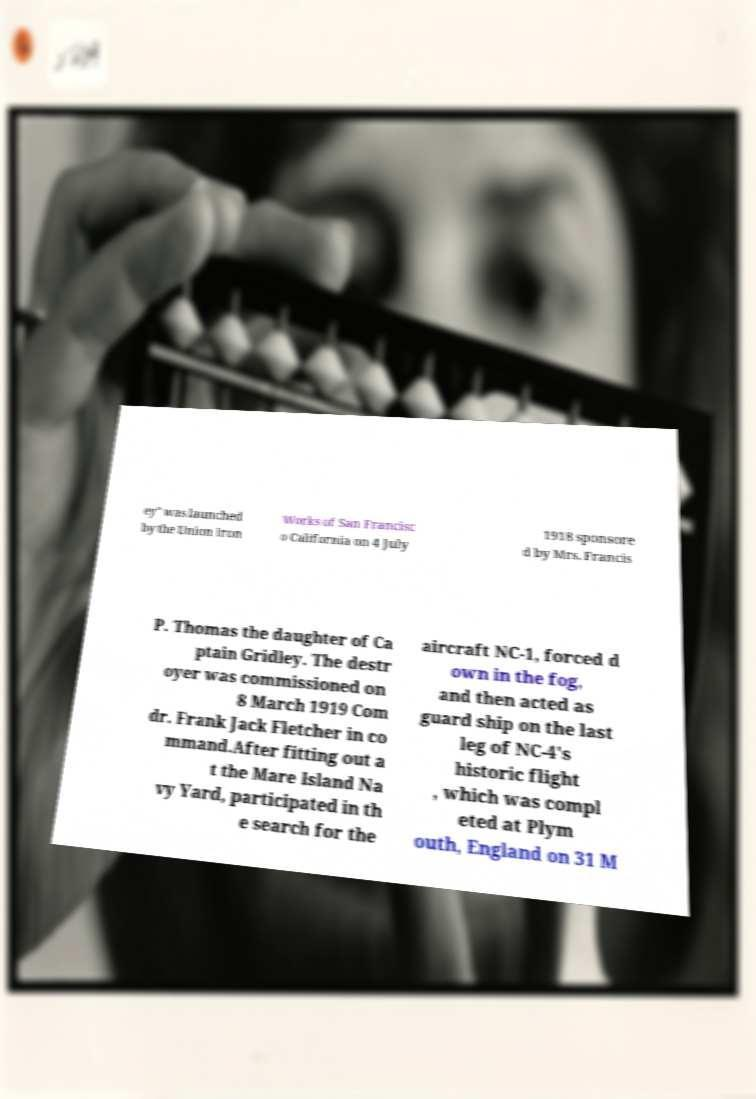Please identify and transcribe the text found in this image. ey" was launched by the Union Iron Works of San Francisc o California on 4 July 1918 sponsore d by Mrs. Francis P. Thomas the daughter of Ca ptain Gridley. The destr oyer was commissioned on 8 March 1919 Com dr. Frank Jack Fletcher in co mmand.After fitting out a t the Mare Island Na vy Yard, participated in th e search for the aircraft NC-1, forced d own in the fog, and then acted as guard ship on the last leg of NC-4's historic flight , which was compl eted at Plym outh, England on 31 M 